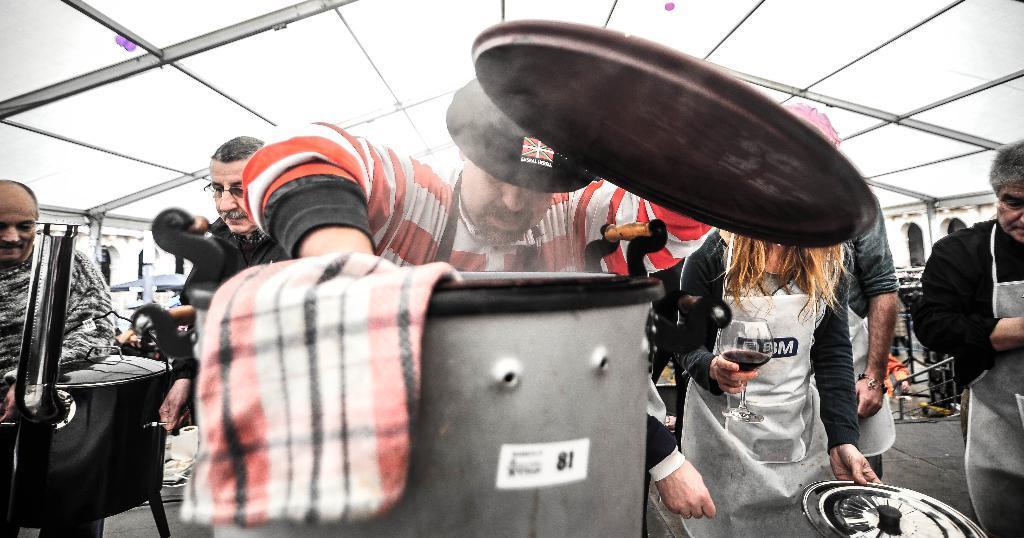Describe this image in one or two sentences. In this image there are people. The person standing on the right is holding a wine glass and a lid. At the bottom there are vessels and we can see a napkin. At the top there is a roof. 